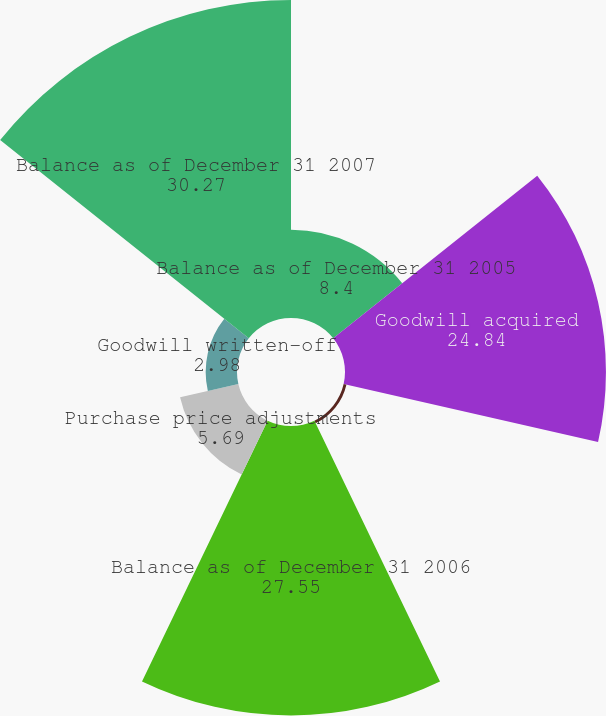Convert chart. <chart><loc_0><loc_0><loc_500><loc_500><pie_chart><fcel>Balance as of December 31 2005<fcel>Goodwill acquired<fcel>Contingent consideration<fcel>Balance as of December 31 2006<fcel>Purchase price adjustments<fcel>Goodwill written-off<fcel>Balance as of December 31 2007<nl><fcel>8.4%<fcel>24.84%<fcel>0.27%<fcel>27.55%<fcel>5.69%<fcel>2.98%<fcel>30.27%<nl></chart> 